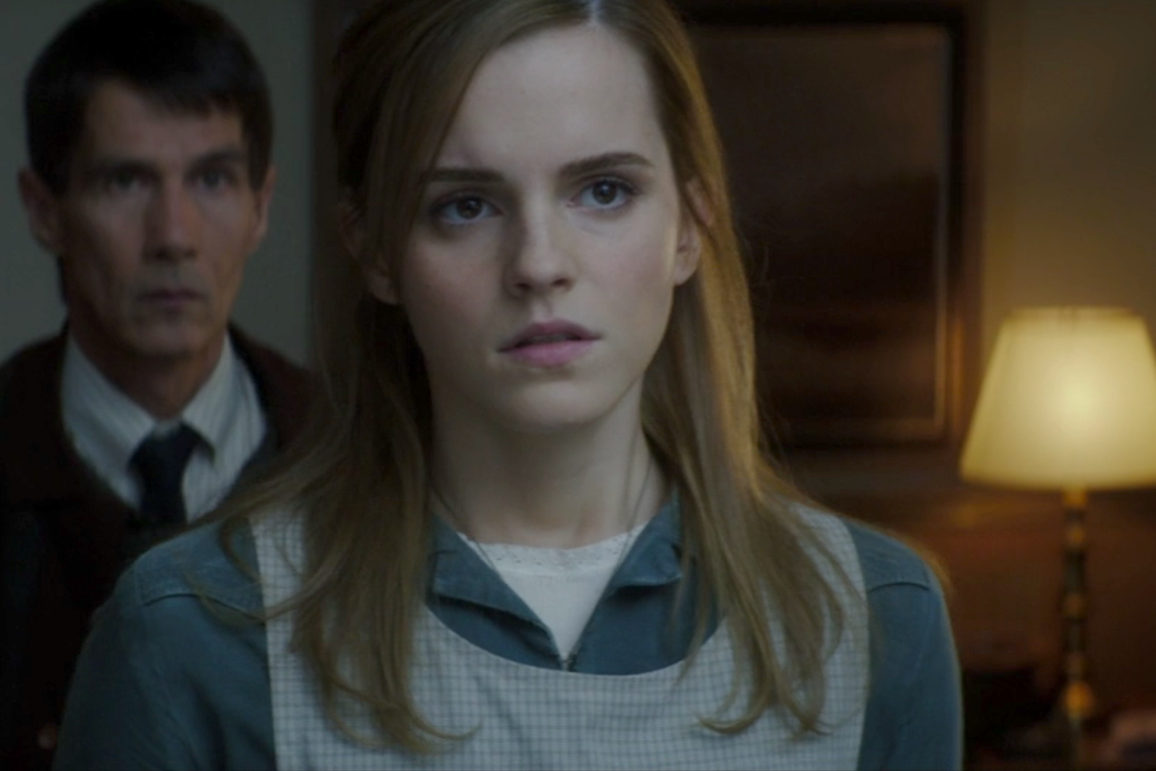What emotions can you perceive in the faces of the individuals shown here? In this image, the woman in the foreground displays a mix of concern and contemplation, as indicated by her wide eyes and slightly parted lips. Her expression suggests she might be grappling with a complex or troubling situation. Meanwhile, the man in the background seems to share a similar emotion, his face tense and his gaze following the sharegpt4v/same direction as the woman's, possibly indicating that they are both focused on the sharegpt4v/same distressing subject or event unfolding before them. 